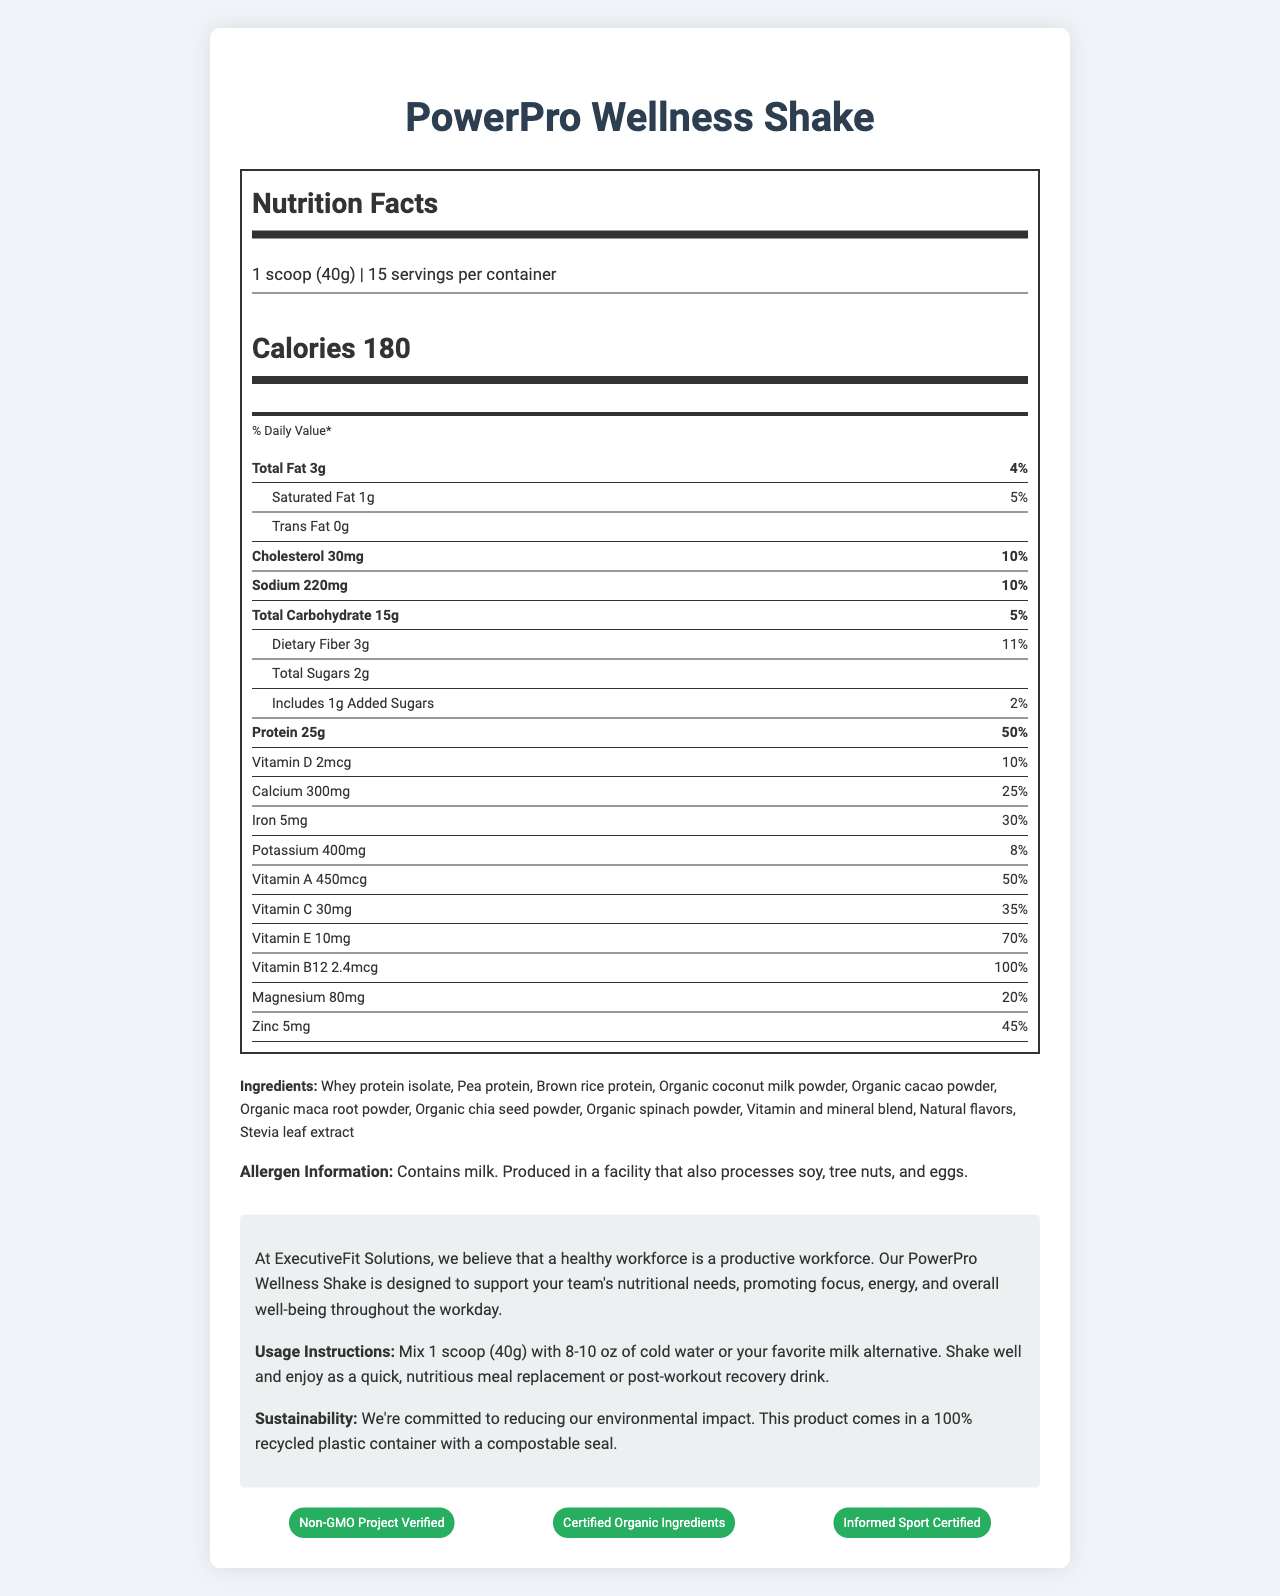How many calories are in one serving of the PowerPro Wellness Shake? The document states that there are 180 calories per serving.
Answer: 180 What is the daily value percentage of protein in one serving? According to the document, one serving of the shake provides 50% of the daily value of protein.
Answer: 50% List three main sources of protein in the PowerPro Wellness Shake. The ingredients list these three sources of protein among its contents.
Answer: Whey protein isolate, Pea protein, Brown rice protein What is the total amount of carbohydrates in each serving? The total amount of carbohydrates per serving is listed as 15g.
Answer: 15g What percentage of the daily value of calcium does one serving provide? Each serving provides 25% of the daily value for calcium.
Answer: 25% Which of the following vitamins has the highest daily value percentage per serving? A. Vitamin D B. Vitamin C C. Vitamin B12 D. Vitamin E Vitamin B12 provides 100% of the daily value per serving, the highest among the listed options.
Answer: C How much dietary fiber does each serving contain? A. 2g B. 3g C. 5g D. 15g Each serving contains 3g of dietary fiber.
Answer: B Is the PowerPro Wellness Shake nut-free? The allergen information indicates that it contains milk and is produced in a facility that processes tree nuts.
Answer: No Summarize the main idea of the document. The document offers a comprehensive overview of the PowerPro Wellness Shake, covering its nutritional benefits, ingredients, and additional relevant information.
Answer: The document provides detailed nutritional information about the PowerPro Wellness Shake, which is a high-protein meal replacement shake. It highlights the nutritional content, ingredients, allergen information, company message, usage instructions, sustainability note, and certifications. Can you find information about the shelf life of the product? The document does not provide any details about the shelf life of the product.
Answer: Not enough information 